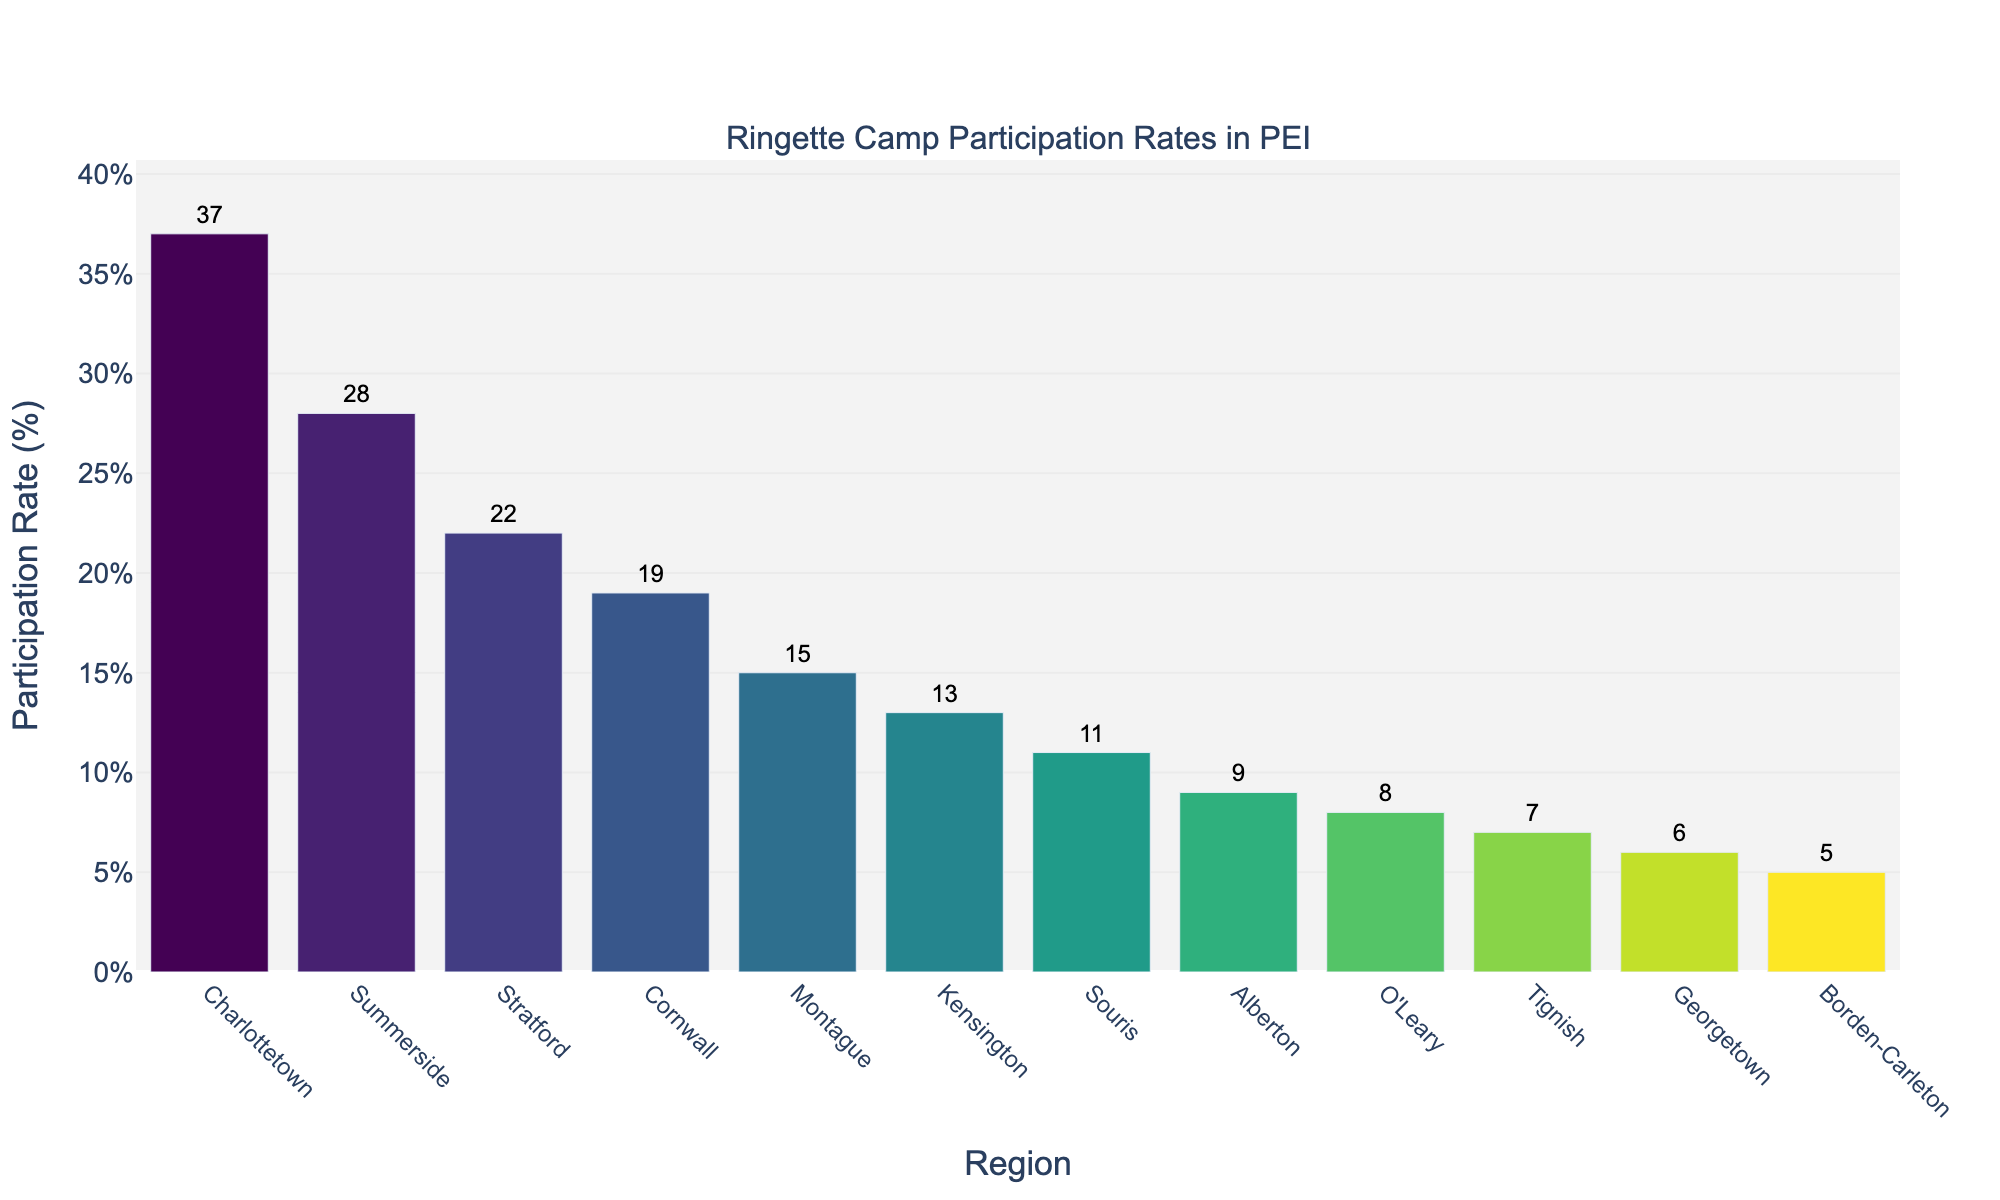What's the highest participation rate among the regions? Identify the tallest bar in the bar chart, which represents the highest participation rate. The tallest bar is for Charlottetown.
Answer: Charlottetown Which region has the lowest participation rate? Look for the shortest bar to determine the lowest participation rate. It belongs to Borden-Carleton.
Answer: Borden-Carleton What is the total participation rate for Stratford and Cornwall combined? Locate the bars for Stratford and Cornwall. Stratford has a participation rate of 22%, Cornwall has 19%. Sum them up: 22 + 19.
Answer: 41% How many regions have a participation rate above 20%? Count the bars that reach above the 20% mark. These regions are Charlottetown, Summerside, and Stratford (3 regions).
Answer: 3 What is the difference in participation rates between Charlottetown and O'Leary? Find the bars for Charlottetown and O'Leary. Charlottetown has 37%, O'Leary has 8%. Calculate the difference: 37 - 8.
Answer: 29% Which region has a participation rate closest to 10%? Observe the bars to find the one nearest to 10%. Souris, with 11%, is the closest.
Answer: Souris What's the average participation rate across all regions? Sum all participation rates: 37 + 28 + 22 + 19 + 15 + 13 + 11 + 9 + 8 + 7 + 6 + 5 = 180. Divide by 12 (number of regions): 180/12.
Answer: 15% Is there a greater difference between the highest and second-highest participation rates or the second-highest and third-highest? Charlottetown (37), Summerside (28), Stratford (22). Difference between highest and second-highest (37-28) is 9. Difference between second-highest and third-highest (28-22) is 6.
Answer: Highest and second-highest 